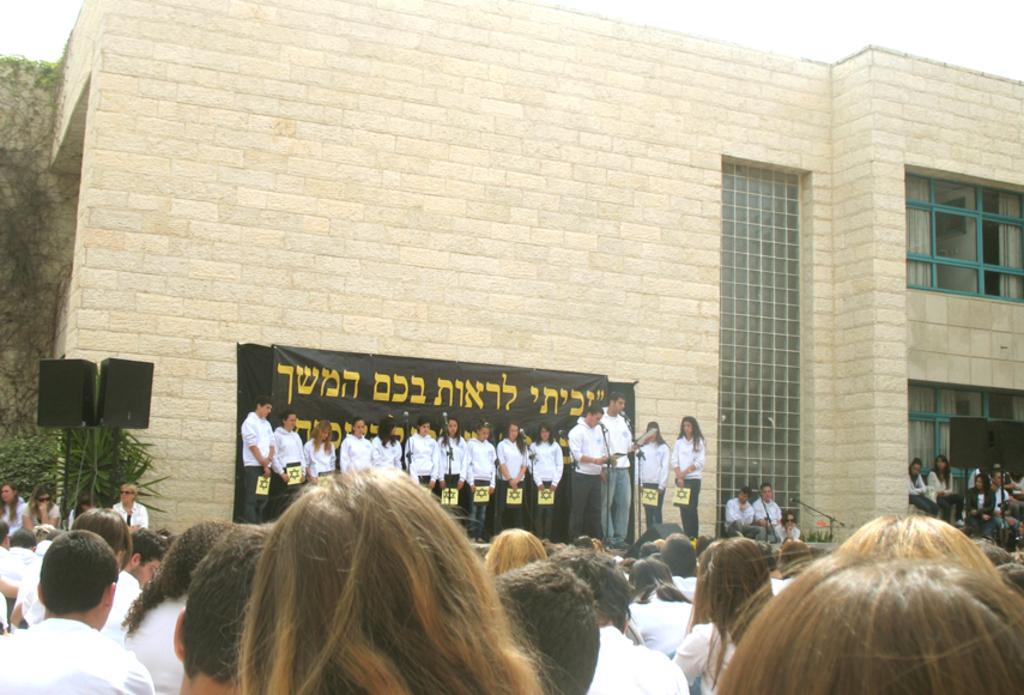Please provide a concise description of this image. At the bottom of the image there are people. In the background of the image there is a building. There are people standing and singing. There is a black color banner. To the left side of the image there are speakers. At the top of the image there is sky. 